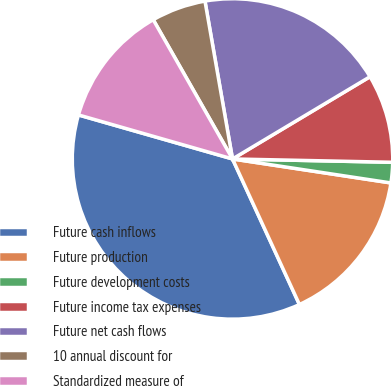<chart> <loc_0><loc_0><loc_500><loc_500><pie_chart><fcel>Future cash inflows<fcel>Future production<fcel>Future development costs<fcel>Future income tax expenses<fcel>Future net cash flows<fcel>10 annual discount for<fcel>Standardized measure of<nl><fcel>36.29%<fcel>15.75%<fcel>2.06%<fcel>8.91%<fcel>19.17%<fcel>5.49%<fcel>12.33%<nl></chart> 